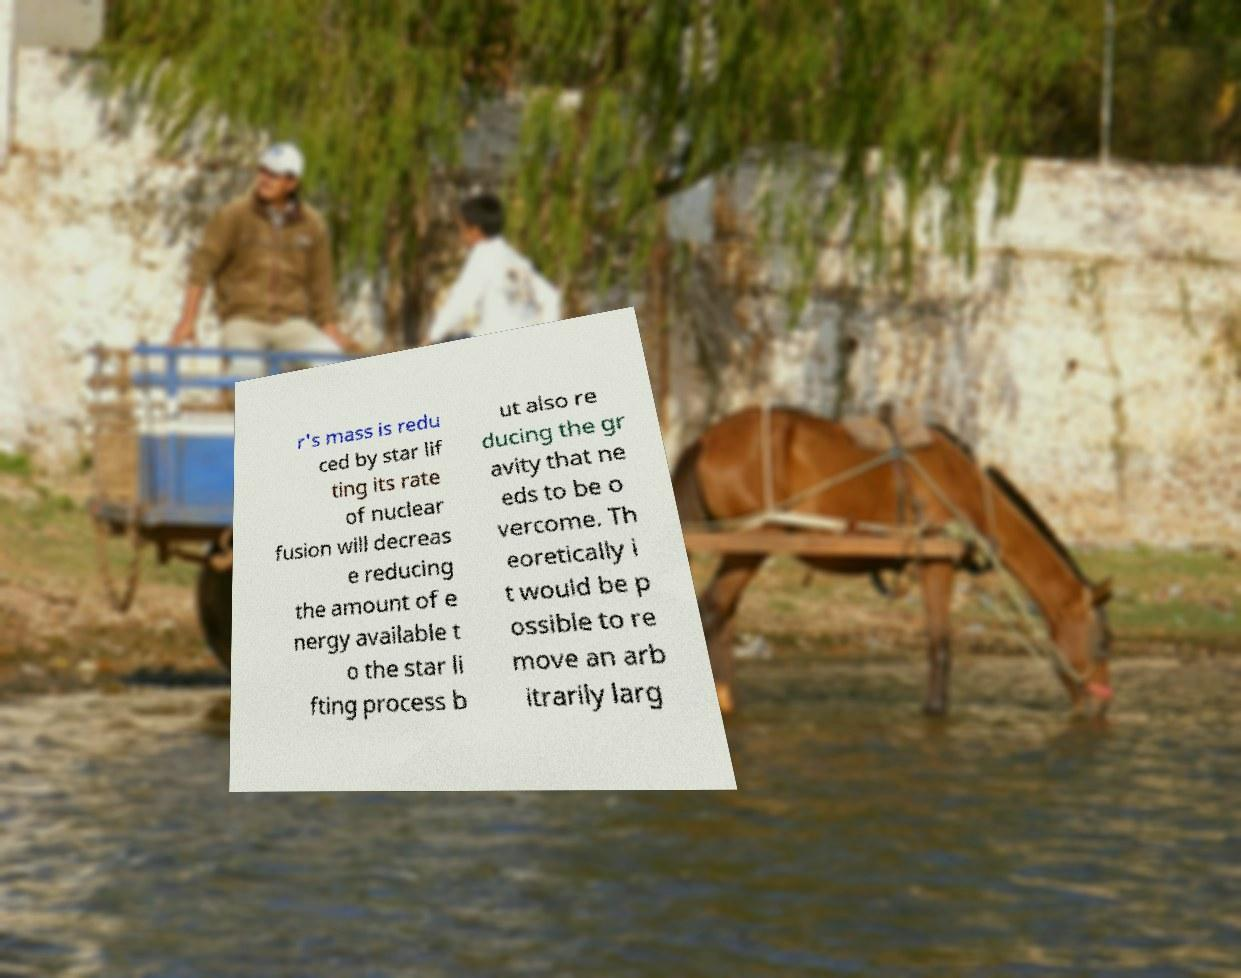I need the written content from this picture converted into text. Can you do that? r's mass is redu ced by star lif ting its rate of nuclear fusion will decreas e reducing the amount of e nergy available t o the star li fting process b ut also re ducing the gr avity that ne eds to be o vercome. Th eoretically i t would be p ossible to re move an arb itrarily larg 